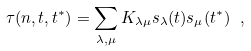Convert formula to latex. <formula><loc_0><loc_0><loc_500><loc_500>\tau ( n , { t } , { t ^ { * } } ) = \sum _ { \lambda , \mu } K _ { \lambda \mu } s _ { \lambda } ( { t } ) s _ { \mu } ( { t ^ { * } } ) \ ,</formula> 